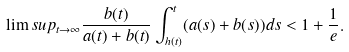Convert formula to latex. <formula><loc_0><loc_0><loc_500><loc_500>\lim s u p _ { t \rightarrow \infty } \frac { b ( t ) } { a ( t ) + b ( t ) } \int _ { h ( t ) } ^ { t } ( a ( s ) + b ( s ) ) d s < 1 + \frac { 1 } { e } .</formula> 